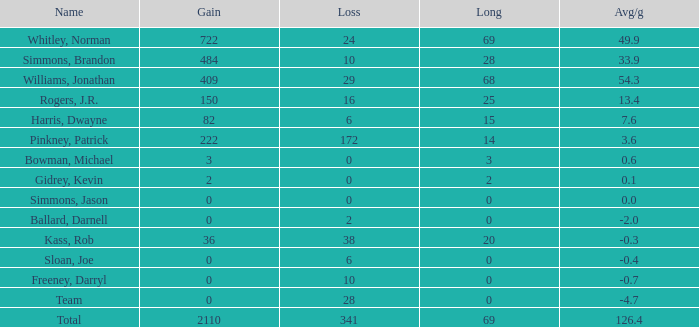Parse the table in full. {'header': ['Name', 'Gain', 'Loss', 'Long', 'Avg/g'], 'rows': [['Whitley, Norman', '722', '24', '69', '49.9'], ['Simmons, Brandon', '484', '10', '28', '33.9'], ['Williams, Jonathan', '409', '29', '68', '54.3'], ['Rogers, J.R.', '150', '16', '25', '13.4'], ['Harris, Dwayne', '82', '6', '15', '7.6'], ['Pinkney, Patrick', '222', '172', '14', '3.6'], ['Bowman, Michael', '3', '0', '3', '0.6'], ['Gidrey, Kevin', '2', '0', '2', '0.1'], ['Simmons, Jason', '0', '0', '0', '0.0'], ['Ballard, Darnell', '0', '2', '0', '-2.0'], ['Kass, Rob', '36', '38', '20', '-0.3'], ['Sloan, Joe', '0', '6', '0', '-0.4'], ['Freeney, Darryl', '0', '10', '0', '-0.7'], ['Team', '0', '28', '0', '-4.7'], ['Total', '2110', '341', '69', '126.4']]} What is the smallest loss value when long is negative? None. 